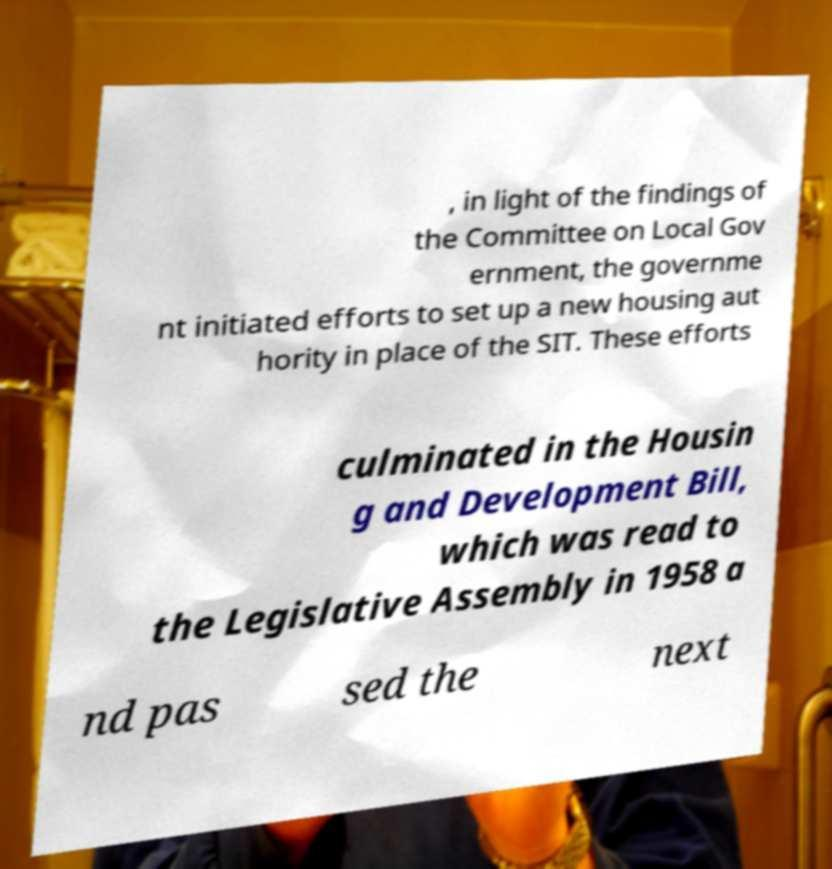Could you extract and type out the text from this image? , in light of the findings of the Committee on Local Gov ernment, the governme nt initiated efforts to set up a new housing aut hority in place of the SIT. These efforts culminated in the Housin g and Development Bill, which was read to the Legislative Assembly in 1958 a nd pas sed the next 